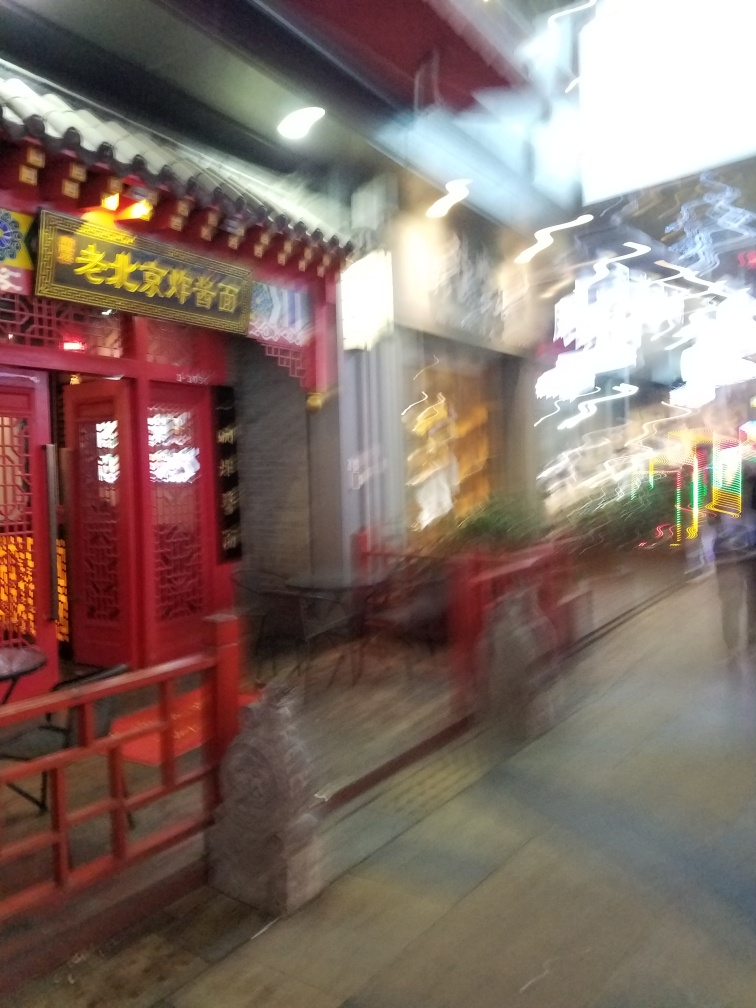Given the decorations and signs, what time of year do you think this photo was taken? Given the brightly lit decorations that can be seen through the blurred photo, it is possible that the picture was taken around a festive period, such as Chinese New Year, when streets are commonly adorned with vibrant lights and decorations to celebrate. 